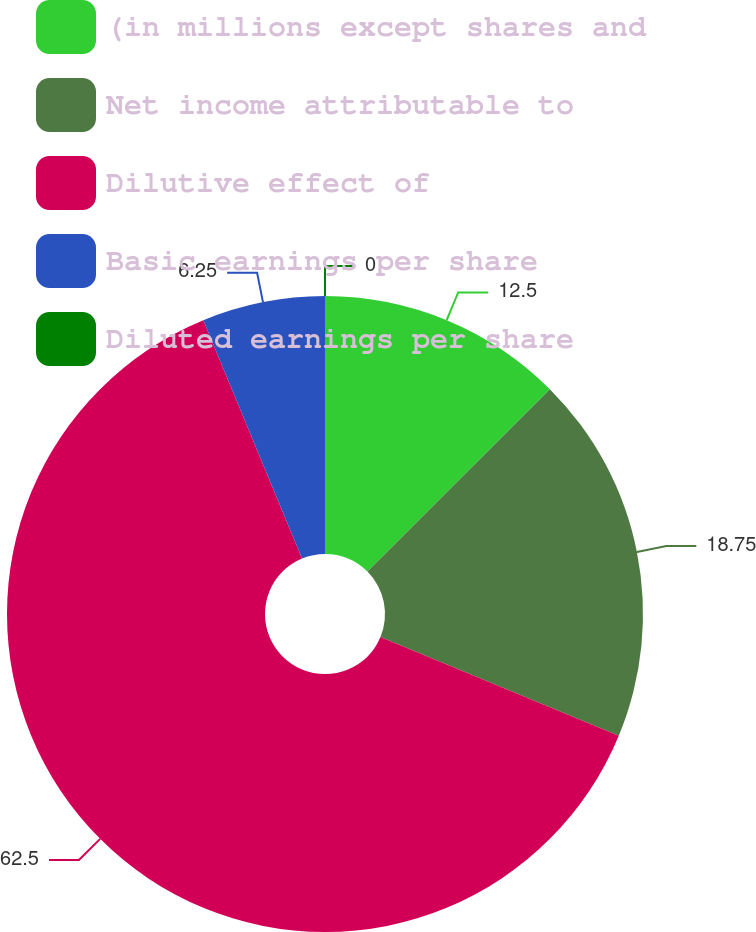Convert chart to OTSL. <chart><loc_0><loc_0><loc_500><loc_500><pie_chart><fcel>(in millions except shares and<fcel>Net income attributable to<fcel>Dilutive effect of<fcel>Basic earnings per share<fcel>Diluted earnings per share<nl><fcel>12.5%<fcel>18.75%<fcel>62.5%<fcel>6.25%<fcel>0.0%<nl></chart> 